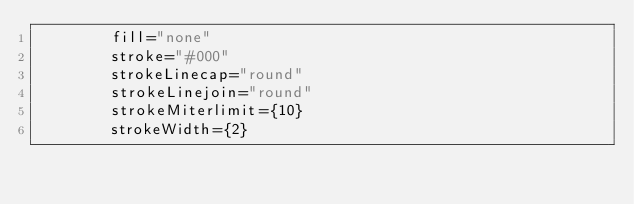<code> <loc_0><loc_0><loc_500><loc_500><_TypeScript_>        fill="none"
        stroke="#000"
        strokeLinecap="round"
        strokeLinejoin="round"
        strokeMiterlimit={10}
        strokeWidth={2}</code> 